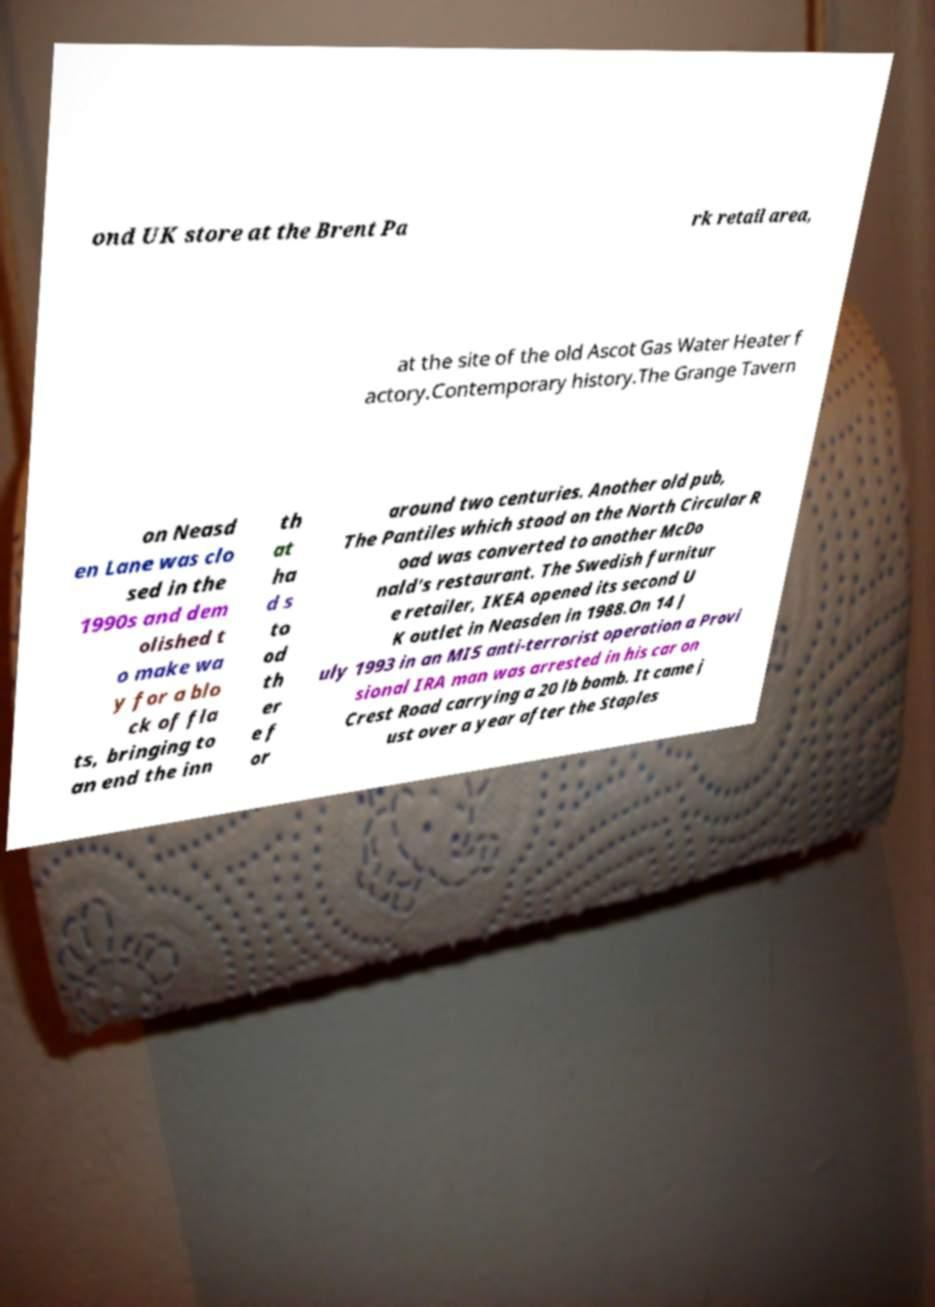Please identify and transcribe the text found in this image. ond UK store at the Brent Pa rk retail area, at the site of the old Ascot Gas Water Heater f actory.Contemporary history.The Grange Tavern on Neasd en Lane was clo sed in the 1990s and dem olished t o make wa y for a blo ck of fla ts, bringing to an end the inn th at ha d s to od th er e f or around two centuries. Another old pub, The Pantiles which stood on the North Circular R oad was converted to another McDo nald's restaurant. The Swedish furnitur e retailer, IKEA opened its second U K outlet in Neasden in 1988.On 14 J uly 1993 in an MI5 anti-terrorist operation a Provi sional IRA man was arrested in his car on Crest Road carrying a 20 lb bomb. It came j ust over a year after the Staples 